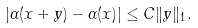<formula> <loc_0><loc_0><loc_500><loc_500>| \alpha ( x + y ) - \alpha ( x ) | \leq C \| y \| _ { 1 } .</formula> 